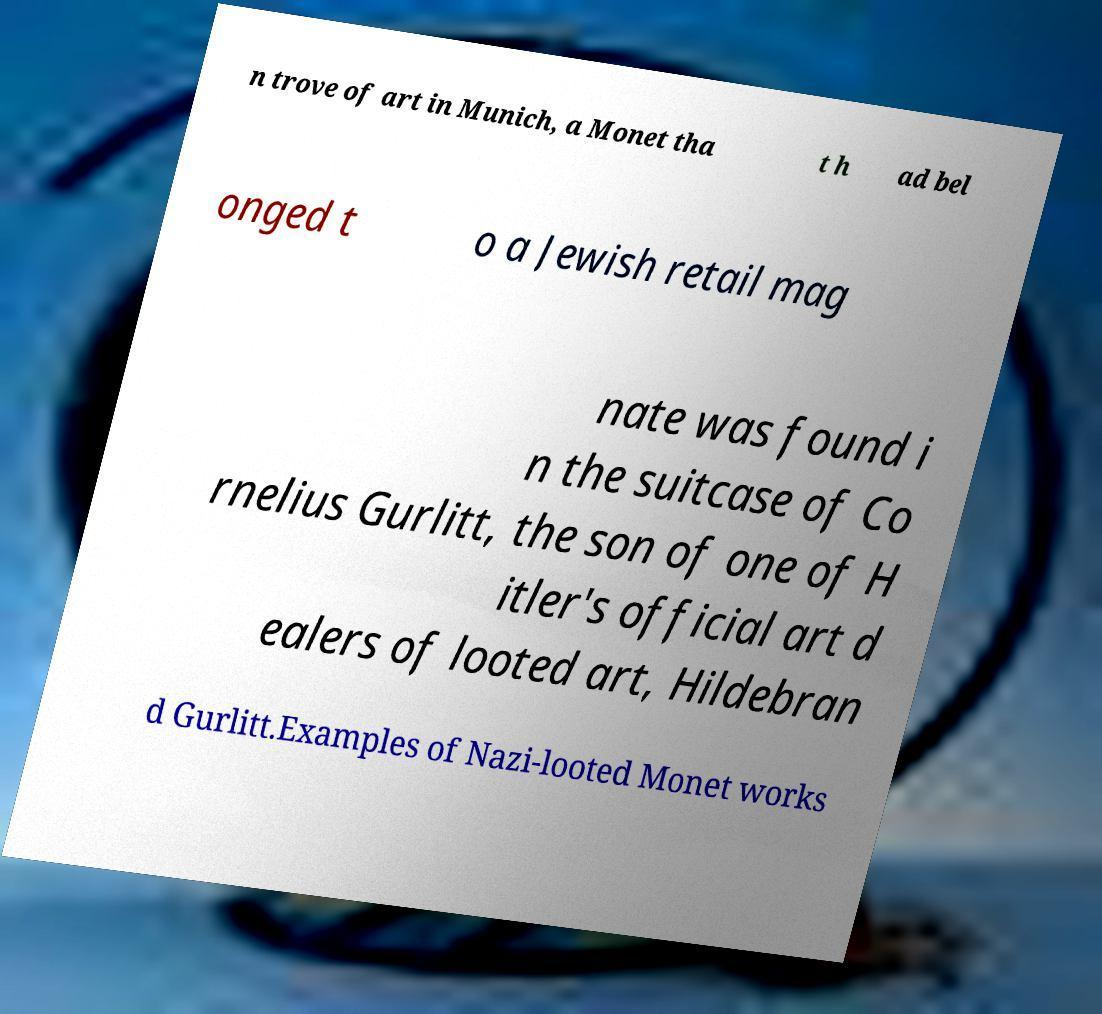Could you extract and type out the text from this image? n trove of art in Munich, a Monet tha t h ad bel onged t o a Jewish retail mag nate was found i n the suitcase of Co rnelius Gurlitt, the son of one of H itler's official art d ealers of looted art, Hildebran d Gurlitt.Examples of Nazi-looted Monet works 